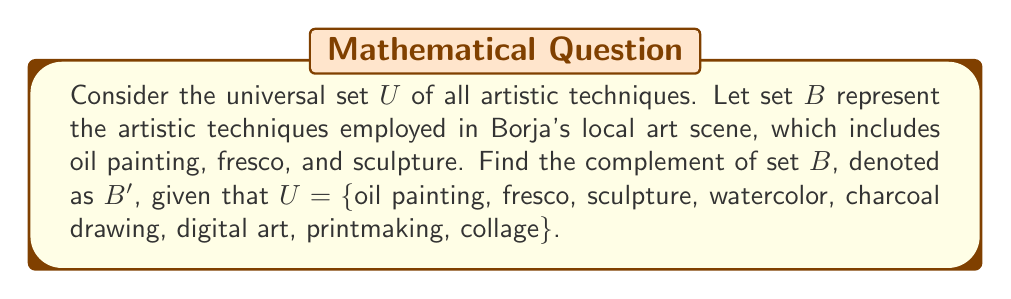Can you answer this question? To find the complement of set $B$, we need to identify all elements in the universal set $U$ that are not in set $B$. Let's approach this step-by-step:

1. First, let's define our sets:
   $U = \{$oil painting, fresco, sculpture, watercolor, charcoal drawing, digital art, printmaking, collage$\}$
   $B = \{$oil painting, fresco, sculpture$\}$

2. The complement of $B$, denoted as $B'$, is defined as:
   $B' = \{x \in U : x \notin B\}$

3. This means we need to identify all elements in $U$ that are not in $B$:
   - watercolor $\in U$ but $\notin B$
   - charcoal drawing $\in U$ but $\notin B$
   - digital art $\in U$ but $\notin B$
   - printmaking $\in U$ but $\notin B$
   - collage $\in U$ but $\notin B$

4. Therefore, the complement of $B$ consists of these elements.

Note: As a fledgling artist focusing on Neo-Classical style, you might find it interesting that the complement includes techniques that are generally not associated with Neo-Classical art, such as digital art and collage.
Answer: $B' = \{$watercolor, charcoal drawing, digital art, printmaking, collage$\}$ 